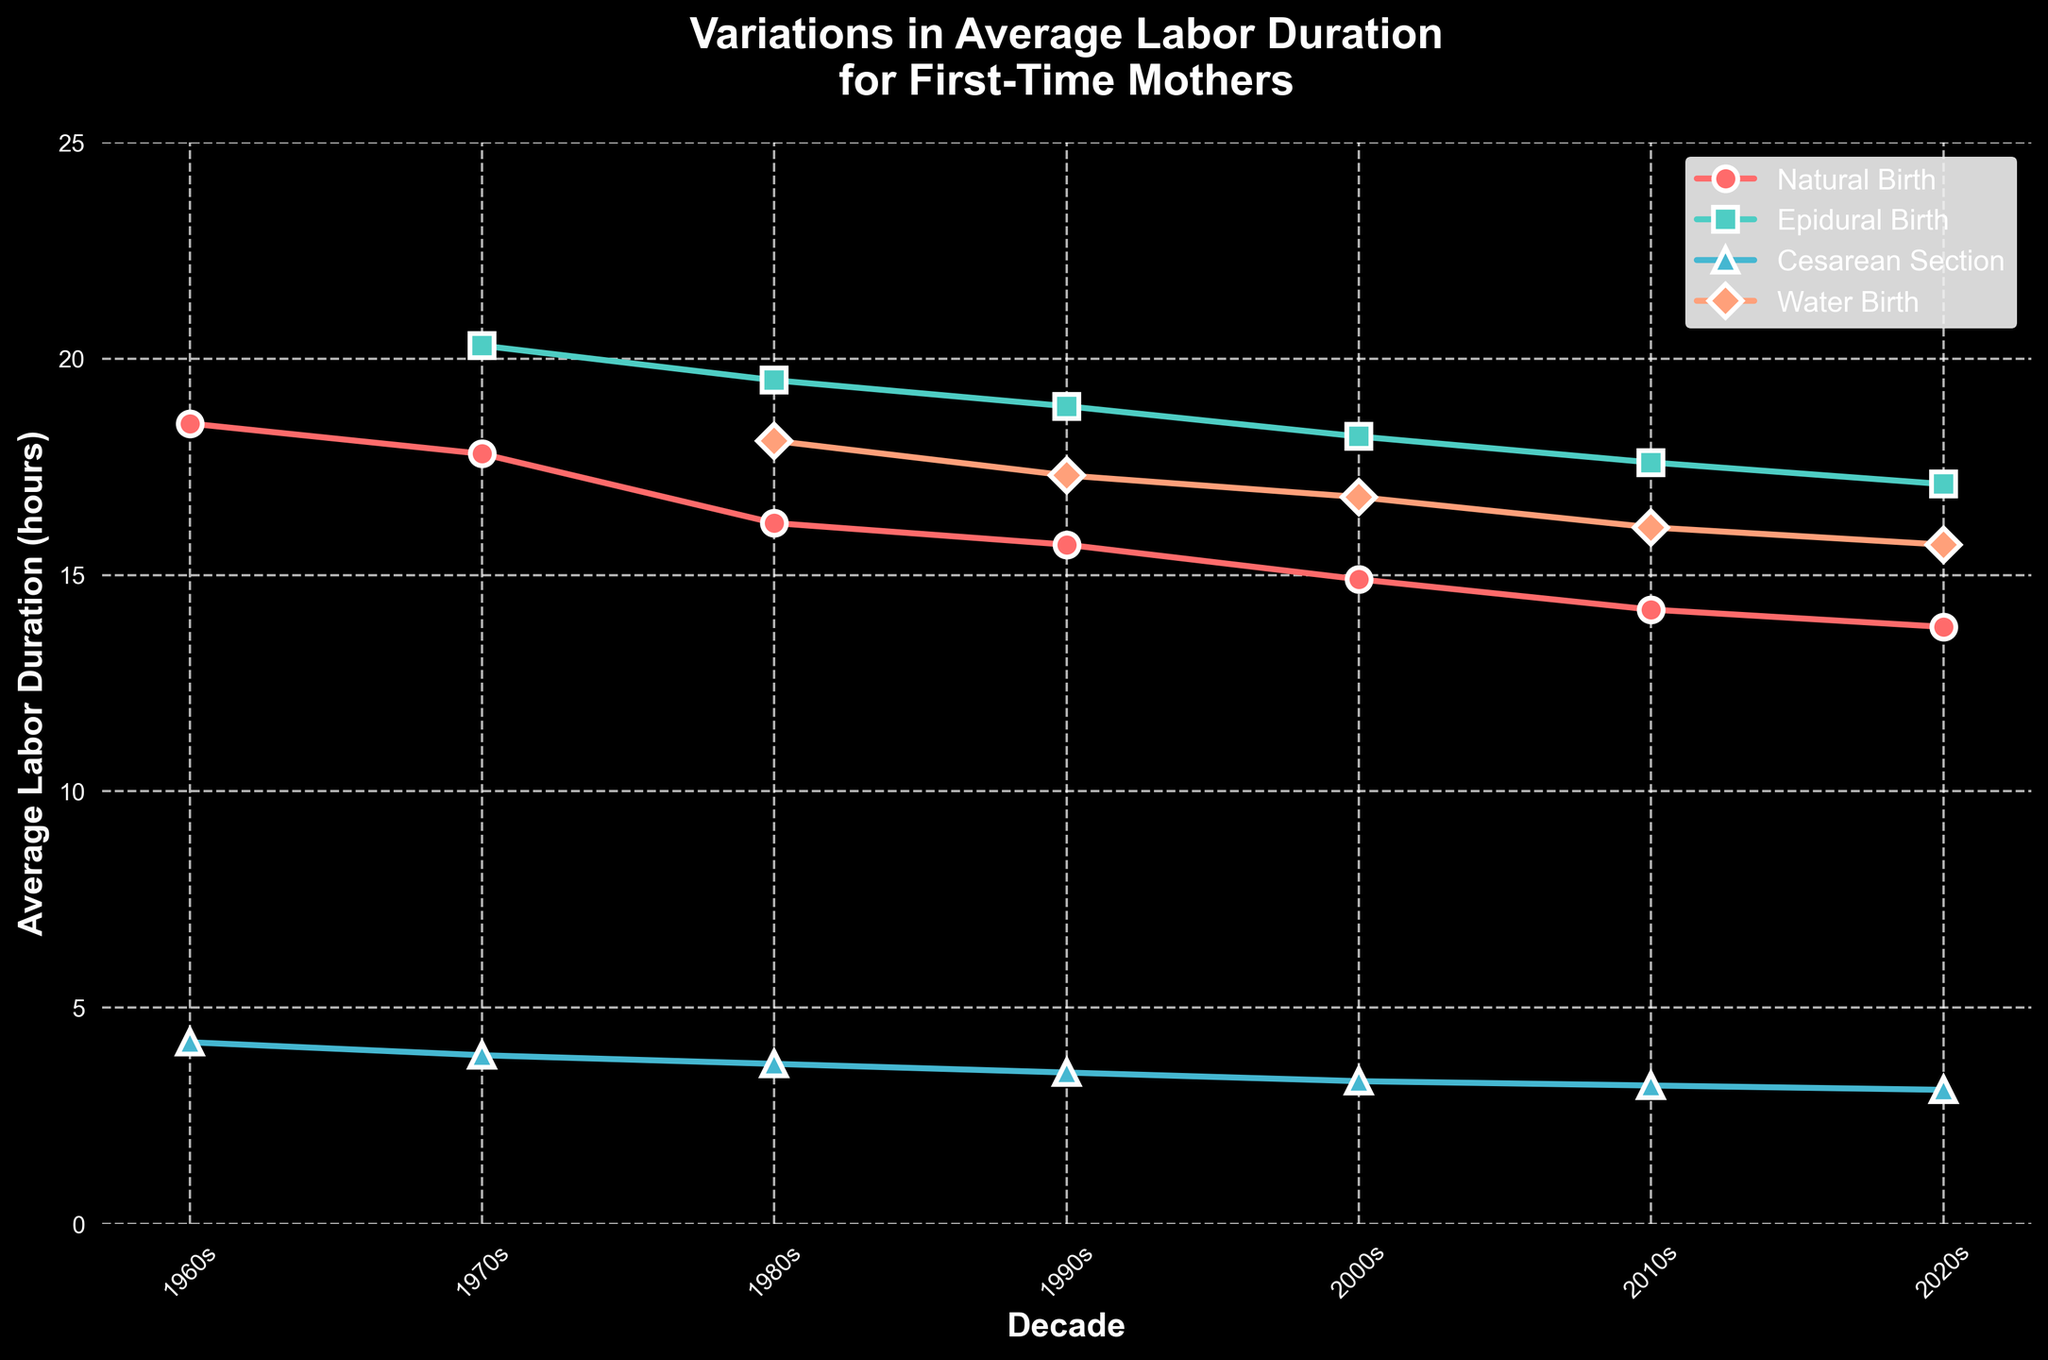What's the trend in average labor duration for Natural Birth from the 1960s to the 2020s? The average labor duration for Natural Birth shows a downward trend over the decades. Starting from 18.5 hours in the 1960s, it consistently decreases each decade to 13.8 hours in the 2020s.
Answer: Downward trend How does the average labor duration for Epidural Birth in the 1980s compare to that in the 2000s? The average labor duration for Epidural Birth in the 1980s is 19.5 hours, while in the 2000s, it is 18.2 hours. There is a decrease in the duration from the 1980s to the 2000s.
Answer: Decrease Which birthing method has the shortest average labor duration in the 2020s? In the 2020s, Cesarean Section has the shortest average labor duration, with 3.1 hours, compared to the other methods.
Answer: Cesarean Section What is the average difference in labor duration between Natural Birth and Water Birth in the 1990s? The average labor duration for Natural Birth in the 1990s is 15.7 hours and for Water Birth is 17.3 hours. The difference is 17.3 - 15.7 = 1.6 hours.
Answer: 1.6 hours Which birthing method exhibits a more noticeable decline in labor duration from the 1960s to the 2020s, Natural Birth or Cesarean Section? Natural Birth declines from 18.5 hours in the 1960s to 13.8 hours in the 2020s (a reduction of 4.7 hours). Cesarean Section declines from 4.2 hours in the 1960s to 3.1 hours in the 2020s (a reduction of 1.1 hours). Therefore, Natural Birth exhibits a more noticeable decline.
Answer: Natural Birth In which decade did Epidural Birth have the highest average labor duration? Epidural Birth had the highest average labor duration in the 1970s, at 20.3 hours.
Answer: 1970s What's the change in average labor duration for Water Birth from the 1980s to the 2020s? In the 1980s, the average labor duration for Water Birth was 18.1 hours, and in the 2020s, it is 15.7 hours. The change is 18.1 - 15.7 = 2.4 hours.
Answer: 2.4 hours How does the average labor duration for Epidural Birth in the 1990s compare to that for Water Birth in the same decade? In the 1990s, the average labor duration for Epidural Birth is 18.9 hours, while for Water Birth it is 17.3 hours. Epidural Birth takes longer by 1.6 hours compared to Water Birth.
Answer: Epidural Birth is longer by 1.6 hours 